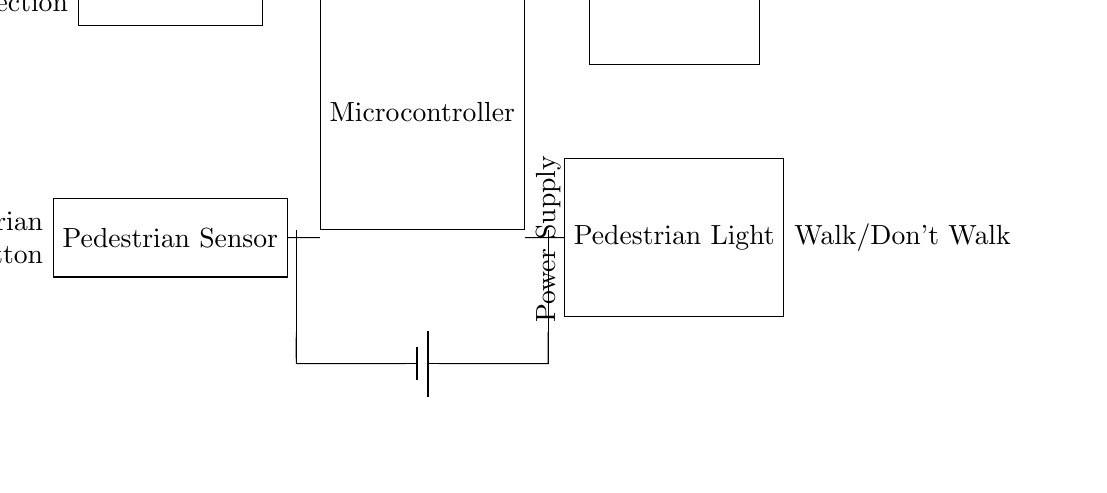What is the main component of this circuit? The main component is the microcontroller, which coordinates signals from sensors and controls the traffic lights.
Answer: microcontroller How many sensors are in the circuit? There are two sensors: a traffic sensor and a pedestrian sensor, which are used to detect vehicle and pedestrian presence.
Answer: two What do the colors of the traffic light represent? The traffic light can display red, yellow, and green, which indicate stop, prepare to stop, and go, respectively.
Answer: Red/Yellow/Green Which device receives input from the pedestrian sensor? The microcontroller receives input from the pedestrian sensor to respond to pedestrian requests at the traffic light.
Answer: microcontroller What type of power supply is used in this circuit? The circuit uses a battery as its power supply to provide the necessary voltage for the components to function.
Answer: battery What outputs does the microcontroller control? The microcontroller controls the traffic light and the pedestrian light, determining when to change their states based on sensor inputs.
Answer: traffic light and pedestrian light 